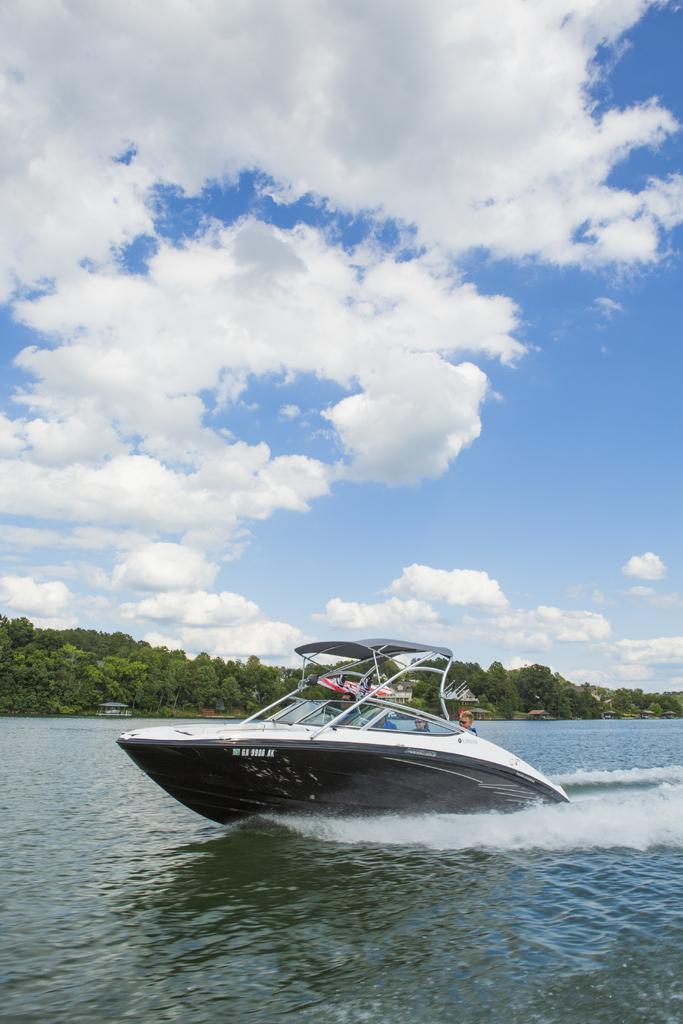In one or two sentences, can you explain what this image depicts? In this image we can see the lake, two boats on the lake, some text on the boat in the middle of the image, some objects in the background near the trees, few people in the boat in the middle of the image, some trees on the ground and at the top there is the cloudy sky. 